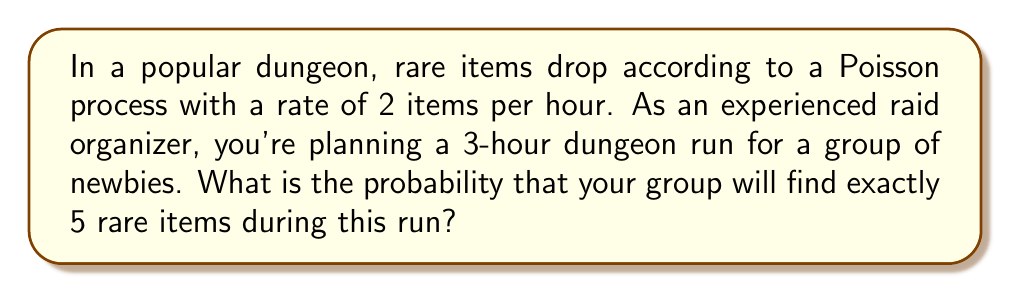Show me your answer to this math problem. Let's approach this step-by-step:

1) We are dealing with a Poisson process, where:
   - λ (rate) = 2 items per hour
   - t (time) = 3 hours
   - k (number of events) = 5 items

2) The mean number of events in time t is:
   $$μ = λt = 2 * 3 = 6$$

3) The probability of exactly k events in a Poisson process is given by the formula:

   $$P(X = k) = \frac{e^{-μ} * μ^k}{k!}$$

4) Substituting our values:

   $$P(X = 5) = \frac{e^{-6} * 6^5}{5!}$$

5) Let's calculate this step-by-step:
   
   $$\frac{e^{-6} * 6^5}{5!} = \frac{0.002479 * 7776}{120} = \frac{19.275}{120} = 0.1606$$

6) Converting to a percentage:

   $$0.1606 * 100 = 16.06\%$$

Thus, the probability of finding exactly 5 rare items during the 3-hour dungeon run is approximately 16.06%.
Answer: 16.06% 